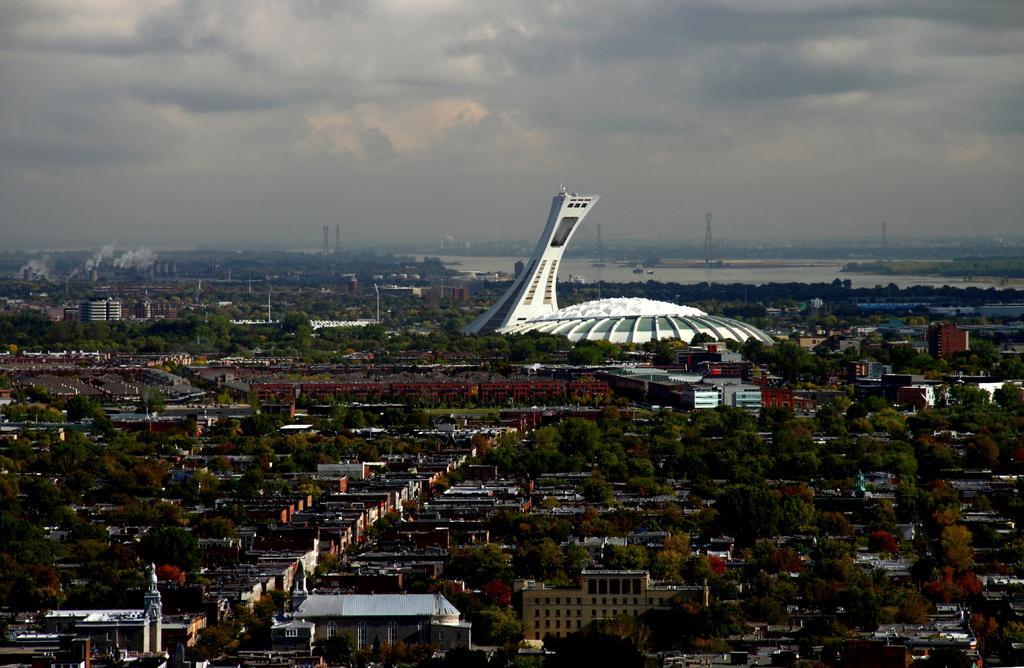Please provide a concise description of this image. These are the houses and trees in this image, in the middle there is a white color construction. At the top it is the cloudy sky. 